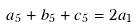Convert formula to latex. <formula><loc_0><loc_0><loc_500><loc_500>a _ { 5 } + b _ { 5 } + c _ { 5 } = 2 a _ { 1 }</formula> 